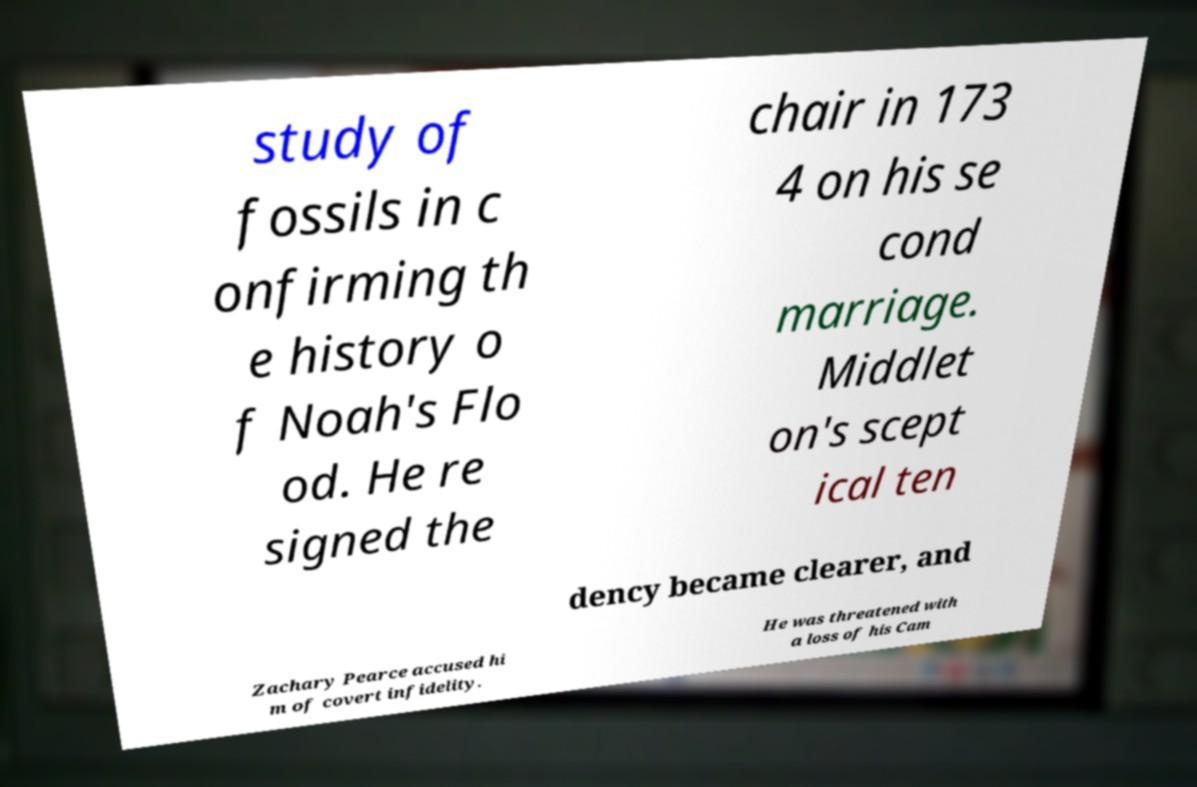What messages or text are displayed in this image? I need them in a readable, typed format. study of fossils in c onfirming th e history o f Noah's Flo od. He re signed the chair in 173 4 on his se cond marriage. Middlet on's scept ical ten dency became clearer, and Zachary Pearce accused hi m of covert infidelity. He was threatened with a loss of his Cam 